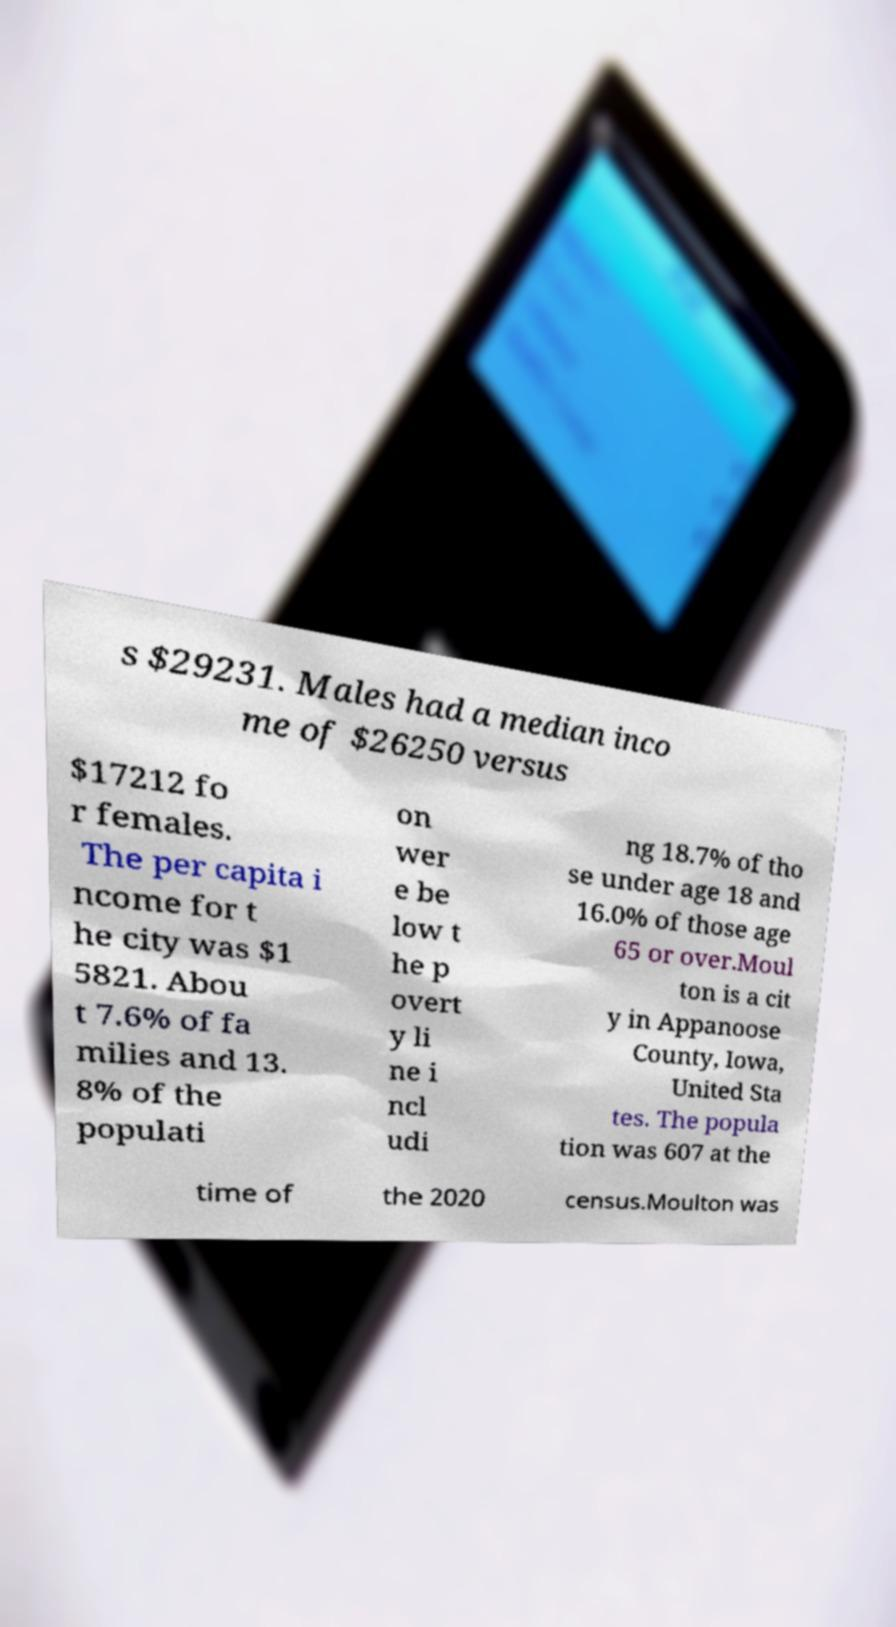Could you assist in decoding the text presented in this image and type it out clearly? s $29231. Males had a median inco me of $26250 versus $17212 fo r females. The per capita i ncome for t he city was $1 5821. Abou t 7.6% of fa milies and 13. 8% of the populati on wer e be low t he p overt y li ne i ncl udi ng 18.7% of tho se under age 18 and 16.0% of those age 65 or over.Moul ton is a cit y in Appanoose County, Iowa, United Sta tes. The popula tion was 607 at the time of the 2020 census.Moulton was 